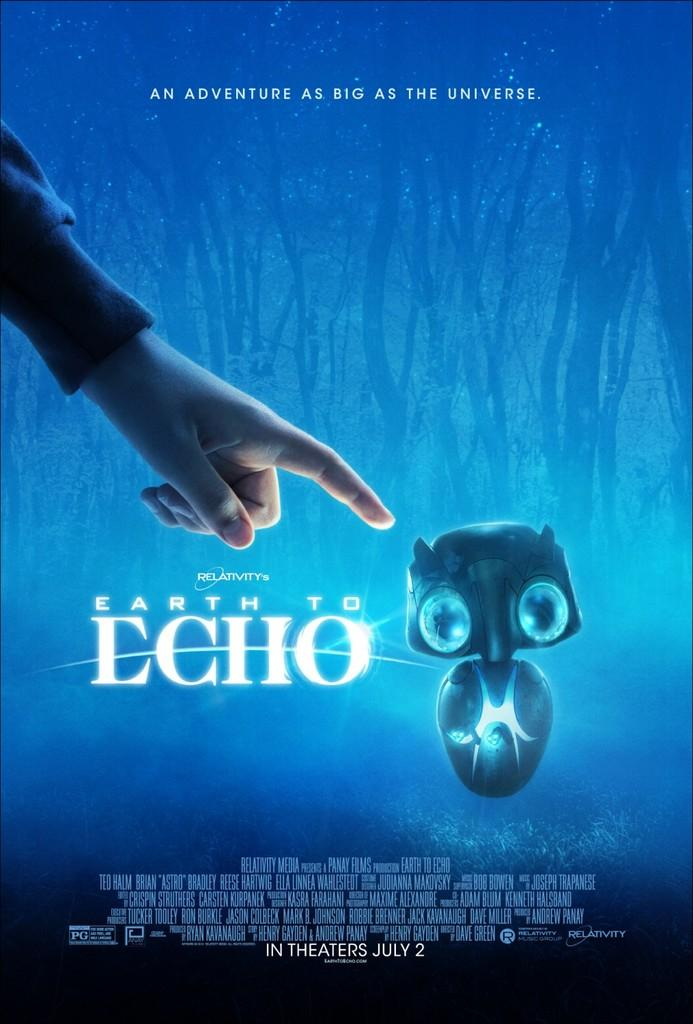<image>
Summarize the visual content of the image. An advertisement for the movie Earth to Echo in theatres July 2. 